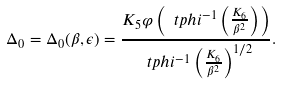<formula> <loc_0><loc_0><loc_500><loc_500>\Delta _ { 0 } = \Delta _ { 0 } ( \beta , \epsilon ) = \frac { K _ { 5 } \varphi \left ( \ t p h i ^ { - 1 } \left ( \frac { K _ { 6 } } { \beta ^ { 2 } } \right ) \right ) } { \ t p h i ^ { - 1 } \left ( \frac { K _ { 6 } } { \beta ^ { 2 } } \right ) ^ { 1 / 2 } } .</formula> 